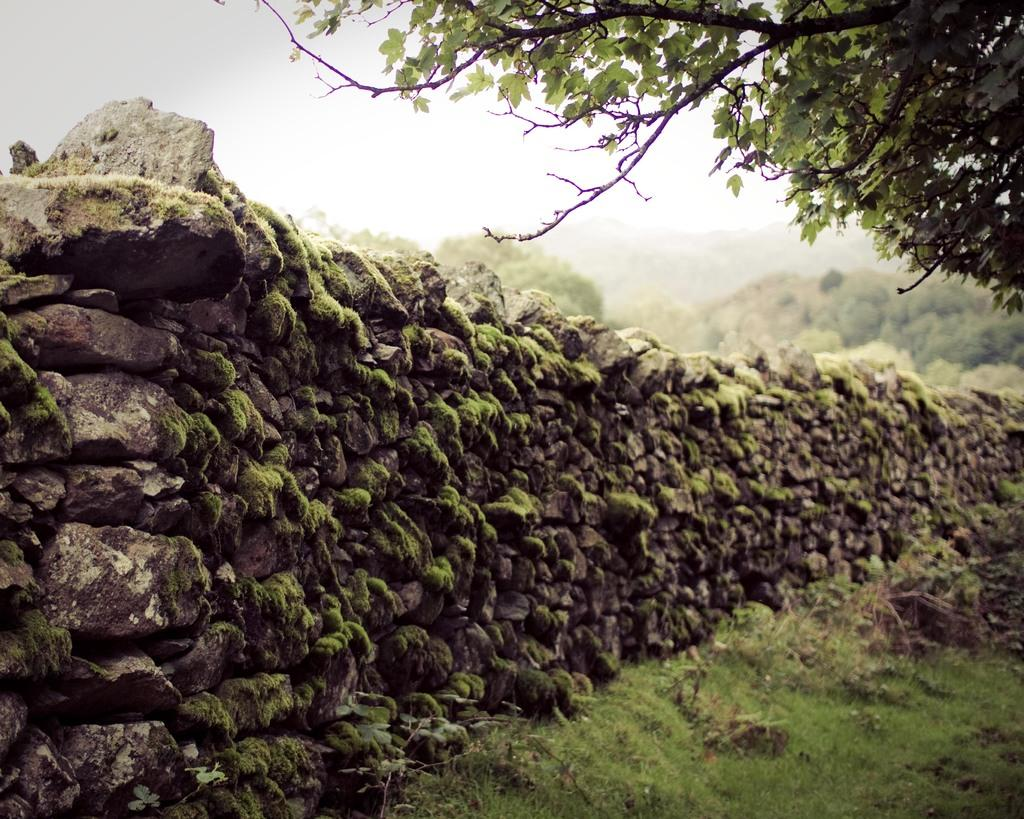What is the main structure in the center of the image? There is a stone wall in the center of the image. What can be seen in the background of the image? There are trees in the background of the image. What part of the sky is visible in the image? The sky is visible at the bottom of the image. What type of pencil can be seen in the image? There is no pencil present in the image. What season is depicted in the image based on the trees and sky? The provided facts do not give enough information to determine the season depicted in the image. 